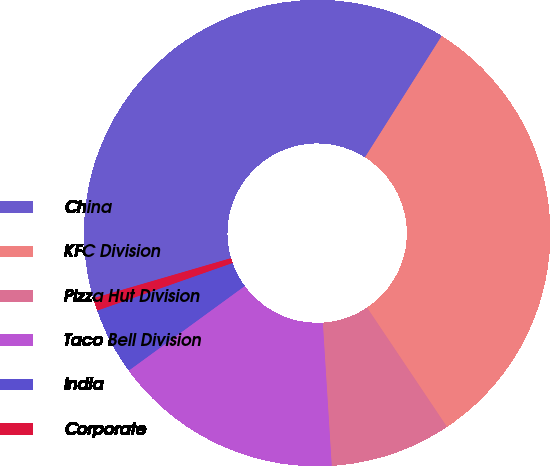Convert chart to OTSL. <chart><loc_0><loc_0><loc_500><loc_500><pie_chart><fcel>China<fcel>KFC Division<fcel>Pizza Hut Division<fcel>Taco Bell Division<fcel>India<fcel>Corporate<nl><fcel>38.47%<fcel>31.63%<fcel>8.4%<fcel>15.96%<fcel>4.64%<fcel>0.88%<nl></chart> 